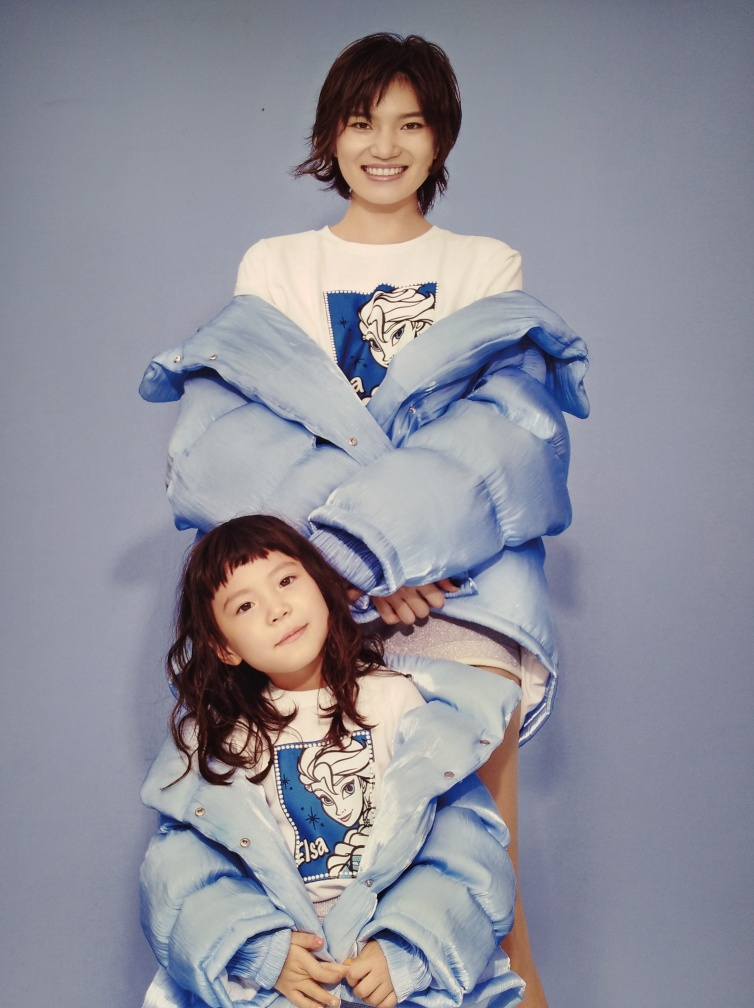Can you describe their outfits? Absolutely. Both individuals are dressed in casual, comfortable attire with a playful and stylish twist. They are wearing oversized denim jackets that give off a modern and fashionable vibe. The printed t-shirts add a youthful element to their ensembles, and their coordinating styles suggest a thematic choice for the photograph. 